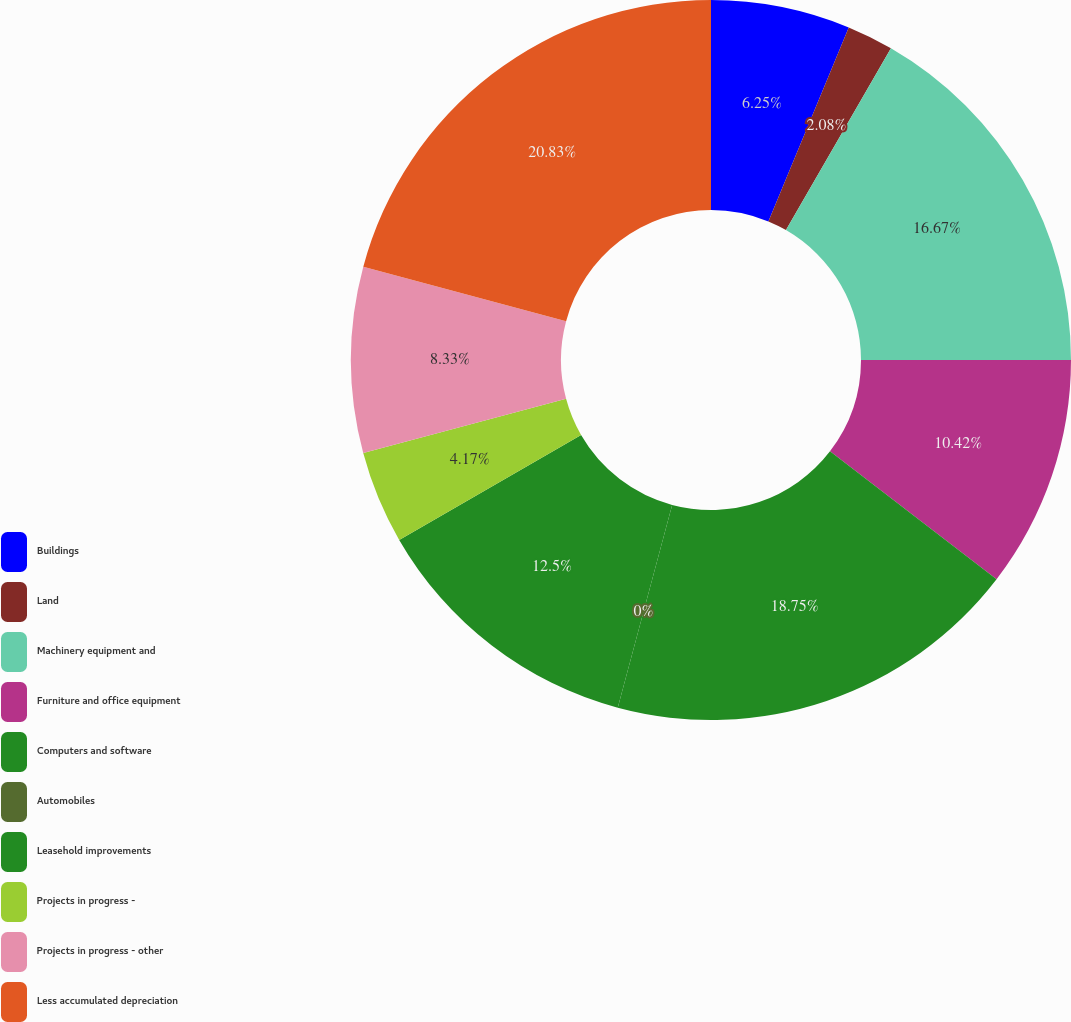Convert chart to OTSL. <chart><loc_0><loc_0><loc_500><loc_500><pie_chart><fcel>Buildings<fcel>Land<fcel>Machinery equipment and<fcel>Furniture and office equipment<fcel>Computers and software<fcel>Automobiles<fcel>Leasehold improvements<fcel>Projects in progress -<fcel>Projects in progress - other<fcel>Less accumulated depreciation<nl><fcel>6.25%<fcel>2.08%<fcel>16.67%<fcel>10.42%<fcel>18.75%<fcel>0.0%<fcel>12.5%<fcel>4.17%<fcel>8.33%<fcel>20.83%<nl></chart> 